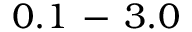Convert formula to latex. <formula><loc_0><loc_0><loc_500><loc_500>0 . 1 \, - \, 3 . 0</formula> 